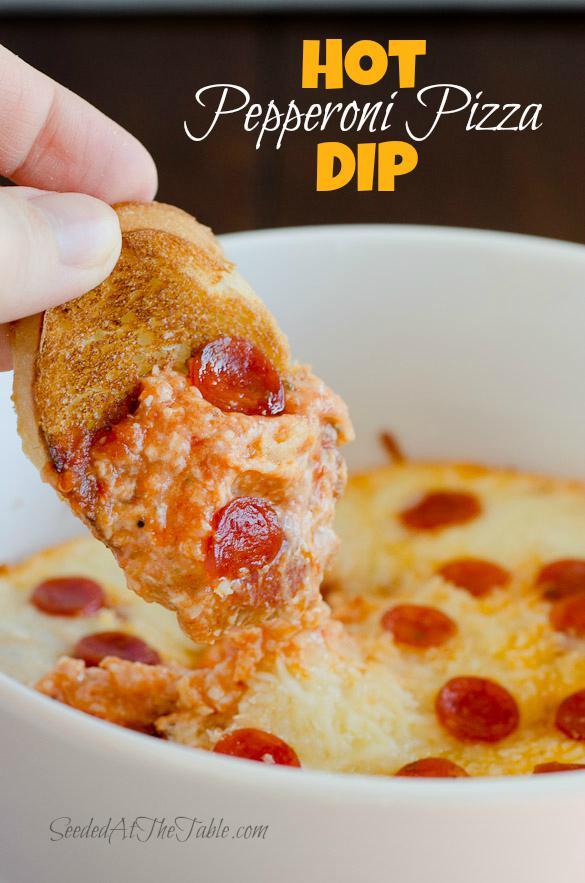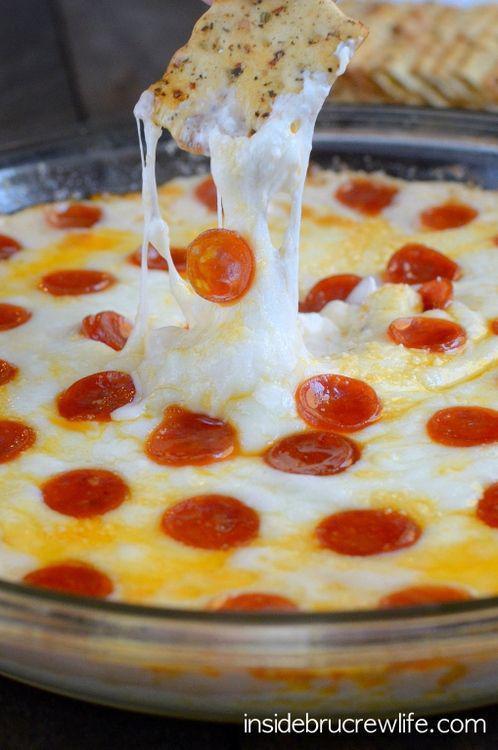The first image is the image on the left, the second image is the image on the right. Evaluate the accuracy of this statement regarding the images: "At least one of the pizzas contains pepperoni.". Is it true? Answer yes or no. Yes. 